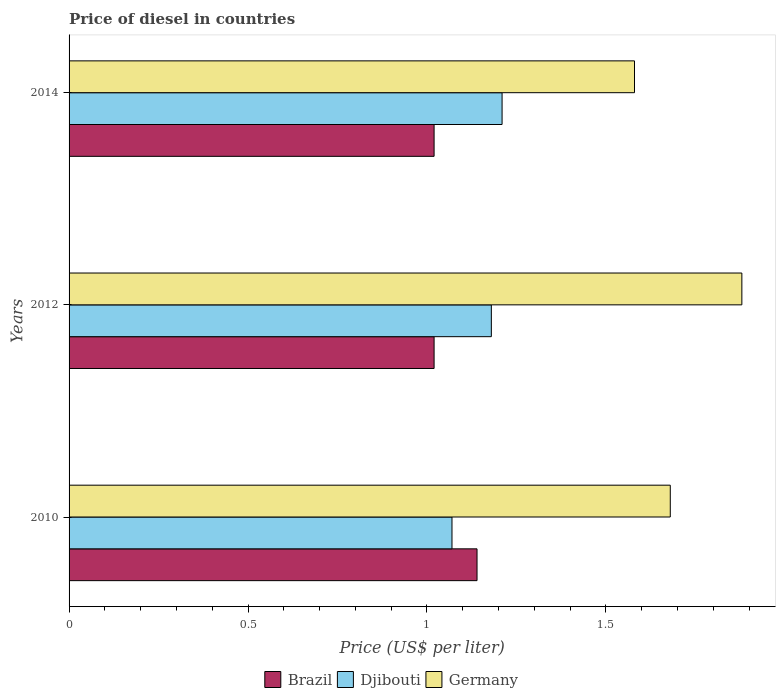How many groups of bars are there?
Provide a succinct answer. 3. Are the number of bars per tick equal to the number of legend labels?
Your response must be concise. Yes. Are the number of bars on each tick of the Y-axis equal?
Make the answer very short. Yes. What is the label of the 1st group of bars from the top?
Provide a short and direct response. 2014. In how many cases, is the number of bars for a given year not equal to the number of legend labels?
Your answer should be compact. 0. What is the price of diesel in Brazil in 2010?
Provide a succinct answer. 1.14. Across all years, what is the maximum price of diesel in Germany?
Keep it short and to the point. 1.88. Across all years, what is the minimum price of diesel in Germany?
Make the answer very short. 1.58. In which year was the price of diesel in Brazil maximum?
Make the answer very short. 2010. In which year was the price of diesel in Brazil minimum?
Ensure brevity in your answer.  2012. What is the total price of diesel in Djibouti in the graph?
Provide a succinct answer. 3.46. What is the difference between the price of diesel in Djibouti in 2010 and that in 2014?
Offer a terse response. -0.14. What is the difference between the price of diesel in Djibouti in 2014 and the price of diesel in Brazil in 2012?
Provide a short and direct response. 0.19. What is the average price of diesel in Djibouti per year?
Provide a succinct answer. 1.15. In the year 2014, what is the difference between the price of diesel in Djibouti and price of diesel in Brazil?
Provide a succinct answer. 0.19. In how many years, is the price of diesel in Djibouti greater than 1.7 US$?
Provide a succinct answer. 0. What is the ratio of the price of diesel in Brazil in 2010 to that in 2012?
Provide a short and direct response. 1.12. Is the difference between the price of diesel in Djibouti in 2010 and 2014 greater than the difference between the price of diesel in Brazil in 2010 and 2014?
Your answer should be compact. No. What is the difference between the highest and the second highest price of diesel in Brazil?
Your answer should be very brief. 0.12. What is the difference between the highest and the lowest price of diesel in Djibouti?
Your response must be concise. 0.14. What does the 1st bar from the top in 2012 represents?
Make the answer very short. Germany. Are the values on the major ticks of X-axis written in scientific E-notation?
Ensure brevity in your answer.  No. Does the graph contain any zero values?
Keep it short and to the point. No. Does the graph contain grids?
Ensure brevity in your answer.  No. Where does the legend appear in the graph?
Ensure brevity in your answer.  Bottom center. How are the legend labels stacked?
Give a very brief answer. Horizontal. What is the title of the graph?
Offer a very short reply. Price of diesel in countries. What is the label or title of the X-axis?
Your answer should be compact. Price (US$ per liter). What is the label or title of the Y-axis?
Ensure brevity in your answer.  Years. What is the Price (US$ per liter) of Brazil in 2010?
Provide a succinct answer. 1.14. What is the Price (US$ per liter) of Djibouti in 2010?
Provide a short and direct response. 1.07. What is the Price (US$ per liter) of Germany in 2010?
Make the answer very short. 1.68. What is the Price (US$ per liter) of Brazil in 2012?
Your response must be concise. 1.02. What is the Price (US$ per liter) in Djibouti in 2012?
Provide a short and direct response. 1.18. What is the Price (US$ per liter) of Germany in 2012?
Give a very brief answer. 1.88. What is the Price (US$ per liter) of Brazil in 2014?
Ensure brevity in your answer.  1.02. What is the Price (US$ per liter) in Djibouti in 2014?
Keep it short and to the point. 1.21. What is the Price (US$ per liter) in Germany in 2014?
Provide a succinct answer. 1.58. Across all years, what is the maximum Price (US$ per liter) in Brazil?
Keep it short and to the point. 1.14. Across all years, what is the maximum Price (US$ per liter) in Djibouti?
Offer a terse response. 1.21. Across all years, what is the maximum Price (US$ per liter) of Germany?
Ensure brevity in your answer.  1.88. Across all years, what is the minimum Price (US$ per liter) of Djibouti?
Your answer should be compact. 1.07. Across all years, what is the minimum Price (US$ per liter) of Germany?
Give a very brief answer. 1.58. What is the total Price (US$ per liter) in Brazil in the graph?
Ensure brevity in your answer.  3.18. What is the total Price (US$ per liter) of Djibouti in the graph?
Your answer should be compact. 3.46. What is the total Price (US$ per liter) in Germany in the graph?
Make the answer very short. 5.14. What is the difference between the Price (US$ per liter) in Brazil in 2010 and that in 2012?
Your response must be concise. 0.12. What is the difference between the Price (US$ per liter) in Djibouti in 2010 and that in 2012?
Your answer should be very brief. -0.11. What is the difference between the Price (US$ per liter) in Germany in 2010 and that in 2012?
Offer a very short reply. -0.2. What is the difference between the Price (US$ per liter) of Brazil in 2010 and that in 2014?
Provide a succinct answer. 0.12. What is the difference between the Price (US$ per liter) of Djibouti in 2010 and that in 2014?
Your answer should be very brief. -0.14. What is the difference between the Price (US$ per liter) of Germany in 2010 and that in 2014?
Your answer should be compact. 0.1. What is the difference between the Price (US$ per liter) in Brazil in 2012 and that in 2014?
Provide a succinct answer. 0. What is the difference between the Price (US$ per liter) in Djibouti in 2012 and that in 2014?
Provide a short and direct response. -0.03. What is the difference between the Price (US$ per liter) in Brazil in 2010 and the Price (US$ per liter) in Djibouti in 2012?
Provide a short and direct response. -0.04. What is the difference between the Price (US$ per liter) in Brazil in 2010 and the Price (US$ per liter) in Germany in 2012?
Your answer should be compact. -0.74. What is the difference between the Price (US$ per liter) of Djibouti in 2010 and the Price (US$ per liter) of Germany in 2012?
Provide a succinct answer. -0.81. What is the difference between the Price (US$ per liter) in Brazil in 2010 and the Price (US$ per liter) in Djibouti in 2014?
Your answer should be very brief. -0.07. What is the difference between the Price (US$ per liter) in Brazil in 2010 and the Price (US$ per liter) in Germany in 2014?
Give a very brief answer. -0.44. What is the difference between the Price (US$ per liter) in Djibouti in 2010 and the Price (US$ per liter) in Germany in 2014?
Keep it short and to the point. -0.51. What is the difference between the Price (US$ per liter) of Brazil in 2012 and the Price (US$ per liter) of Djibouti in 2014?
Give a very brief answer. -0.19. What is the difference between the Price (US$ per liter) of Brazil in 2012 and the Price (US$ per liter) of Germany in 2014?
Your answer should be very brief. -0.56. What is the average Price (US$ per liter) in Brazil per year?
Give a very brief answer. 1.06. What is the average Price (US$ per liter) in Djibouti per year?
Offer a very short reply. 1.15. What is the average Price (US$ per liter) of Germany per year?
Give a very brief answer. 1.71. In the year 2010, what is the difference between the Price (US$ per liter) of Brazil and Price (US$ per liter) of Djibouti?
Provide a short and direct response. 0.07. In the year 2010, what is the difference between the Price (US$ per liter) in Brazil and Price (US$ per liter) in Germany?
Make the answer very short. -0.54. In the year 2010, what is the difference between the Price (US$ per liter) of Djibouti and Price (US$ per liter) of Germany?
Your answer should be very brief. -0.61. In the year 2012, what is the difference between the Price (US$ per liter) of Brazil and Price (US$ per liter) of Djibouti?
Make the answer very short. -0.16. In the year 2012, what is the difference between the Price (US$ per liter) of Brazil and Price (US$ per liter) of Germany?
Provide a succinct answer. -0.86. In the year 2014, what is the difference between the Price (US$ per liter) in Brazil and Price (US$ per liter) in Djibouti?
Your answer should be compact. -0.19. In the year 2014, what is the difference between the Price (US$ per liter) of Brazil and Price (US$ per liter) of Germany?
Your response must be concise. -0.56. In the year 2014, what is the difference between the Price (US$ per liter) in Djibouti and Price (US$ per liter) in Germany?
Offer a terse response. -0.37. What is the ratio of the Price (US$ per liter) of Brazil in 2010 to that in 2012?
Provide a succinct answer. 1.12. What is the ratio of the Price (US$ per liter) of Djibouti in 2010 to that in 2012?
Offer a very short reply. 0.91. What is the ratio of the Price (US$ per liter) in Germany in 2010 to that in 2012?
Offer a very short reply. 0.89. What is the ratio of the Price (US$ per liter) in Brazil in 2010 to that in 2014?
Give a very brief answer. 1.12. What is the ratio of the Price (US$ per liter) of Djibouti in 2010 to that in 2014?
Provide a succinct answer. 0.88. What is the ratio of the Price (US$ per liter) of Germany in 2010 to that in 2014?
Your response must be concise. 1.06. What is the ratio of the Price (US$ per liter) of Brazil in 2012 to that in 2014?
Keep it short and to the point. 1. What is the ratio of the Price (US$ per liter) of Djibouti in 2012 to that in 2014?
Ensure brevity in your answer.  0.98. What is the ratio of the Price (US$ per liter) of Germany in 2012 to that in 2014?
Your answer should be compact. 1.19. What is the difference between the highest and the second highest Price (US$ per liter) in Brazil?
Provide a short and direct response. 0.12. What is the difference between the highest and the lowest Price (US$ per liter) in Brazil?
Make the answer very short. 0.12. What is the difference between the highest and the lowest Price (US$ per liter) of Djibouti?
Offer a terse response. 0.14. 